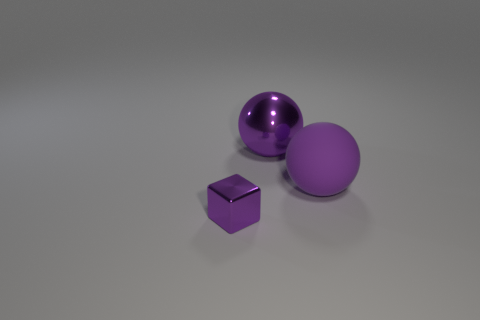Add 3 small cyan rubber objects. How many objects exist? 6 Subtract all spheres. How many objects are left? 1 Add 2 purple matte objects. How many purple matte objects exist? 3 Subtract 0 gray spheres. How many objects are left? 3 Subtract all large rubber blocks. Subtract all tiny purple metallic objects. How many objects are left? 2 Add 3 tiny objects. How many tiny objects are left? 4 